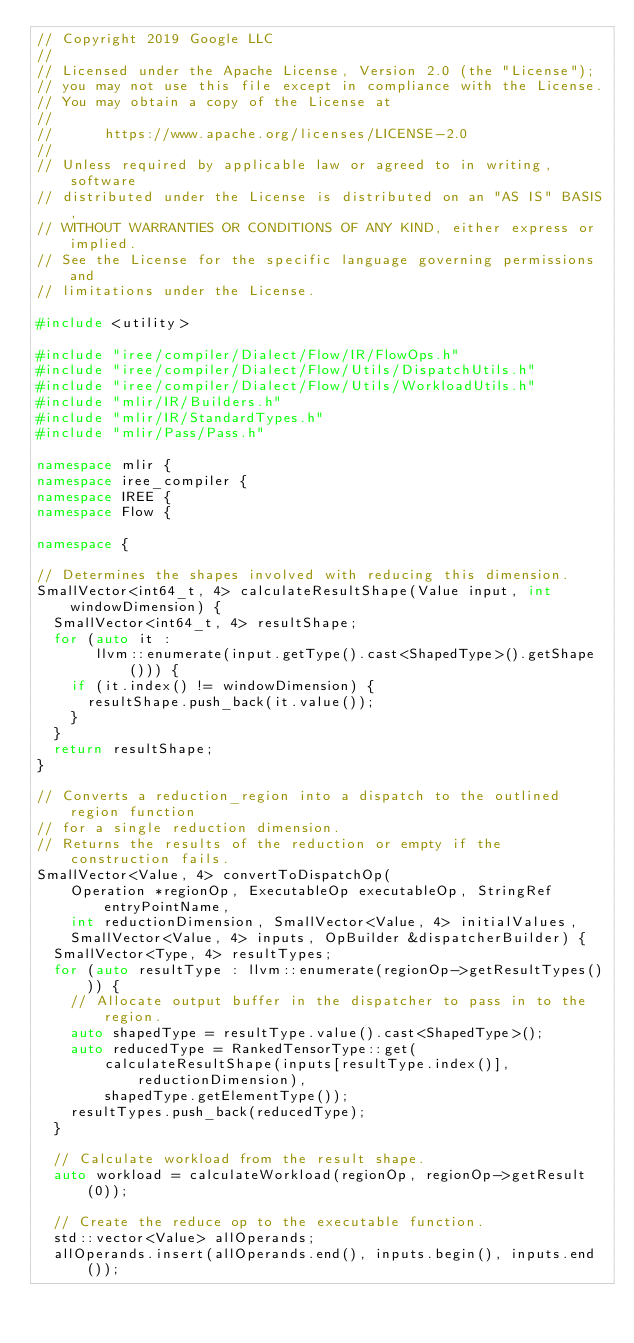<code> <loc_0><loc_0><loc_500><loc_500><_C++_>// Copyright 2019 Google LLC
//
// Licensed under the Apache License, Version 2.0 (the "License");
// you may not use this file except in compliance with the License.
// You may obtain a copy of the License at
//
//      https://www.apache.org/licenses/LICENSE-2.0
//
// Unless required by applicable law or agreed to in writing, software
// distributed under the License is distributed on an "AS IS" BASIS,
// WITHOUT WARRANTIES OR CONDITIONS OF ANY KIND, either express or implied.
// See the License for the specific language governing permissions and
// limitations under the License.

#include <utility>

#include "iree/compiler/Dialect/Flow/IR/FlowOps.h"
#include "iree/compiler/Dialect/Flow/Utils/DispatchUtils.h"
#include "iree/compiler/Dialect/Flow/Utils/WorkloadUtils.h"
#include "mlir/IR/Builders.h"
#include "mlir/IR/StandardTypes.h"
#include "mlir/Pass/Pass.h"

namespace mlir {
namespace iree_compiler {
namespace IREE {
namespace Flow {

namespace {

// Determines the shapes involved with reducing this dimension.
SmallVector<int64_t, 4> calculateResultShape(Value input, int windowDimension) {
  SmallVector<int64_t, 4> resultShape;
  for (auto it :
       llvm::enumerate(input.getType().cast<ShapedType>().getShape())) {
    if (it.index() != windowDimension) {
      resultShape.push_back(it.value());
    }
  }
  return resultShape;
}

// Converts a reduction_region into a dispatch to the outlined region function
// for a single reduction dimension.
// Returns the results of the reduction or empty if the construction fails.
SmallVector<Value, 4> convertToDispatchOp(
    Operation *regionOp, ExecutableOp executableOp, StringRef entryPointName,
    int reductionDimension, SmallVector<Value, 4> initialValues,
    SmallVector<Value, 4> inputs, OpBuilder &dispatcherBuilder) {
  SmallVector<Type, 4> resultTypes;
  for (auto resultType : llvm::enumerate(regionOp->getResultTypes())) {
    // Allocate output buffer in the dispatcher to pass in to the region.
    auto shapedType = resultType.value().cast<ShapedType>();
    auto reducedType = RankedTensorType::get(
        calculateResultShape(inputs[resultType.index()], reductionDimension),
        shapedType.getElementType());
    resultTypes.push_back(reducedType);
  }

  // Calculate workload from the result shape.
  auto workload = calculateWorkload(regionOp, regionOp->getResult(0));

  // Create the reduce op to the executable function.
  std::vector<Value> allOperands;
  allOperands.insert(allOperands.end(), inputs.begin(), inputs.end());</code> 